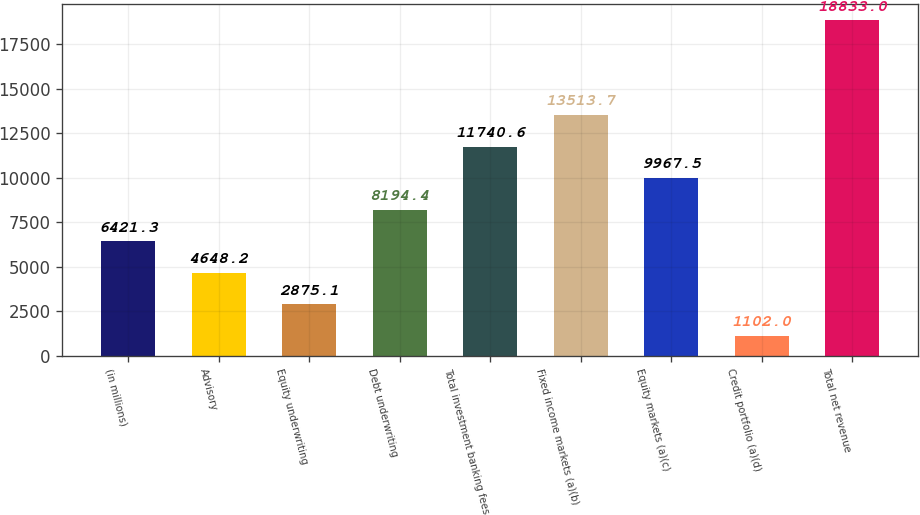Convert chart to OTSL. <chart><loc_0><loc_0><loc_500><loc_500><bar_chart><fcel>(in millions)<fcel>Advisory<fcel>Equity underwriting<fcel>Debt underwriting<fcel>Total investment banking fees<fcel>Fixed income markets (a)(b)<fcel>Equity markets (a)(c)<fcel>Credit portfolio (a)(d)<fcel>Total net revenue<nl><fcel>6421.3<fcel>4648.2<fcel>2875.1<fcel>8194.4<fcel>11740.6<fcel>13513.7<fcel>9967.5<fcel>1102<fcel>18833<nl></chart> 